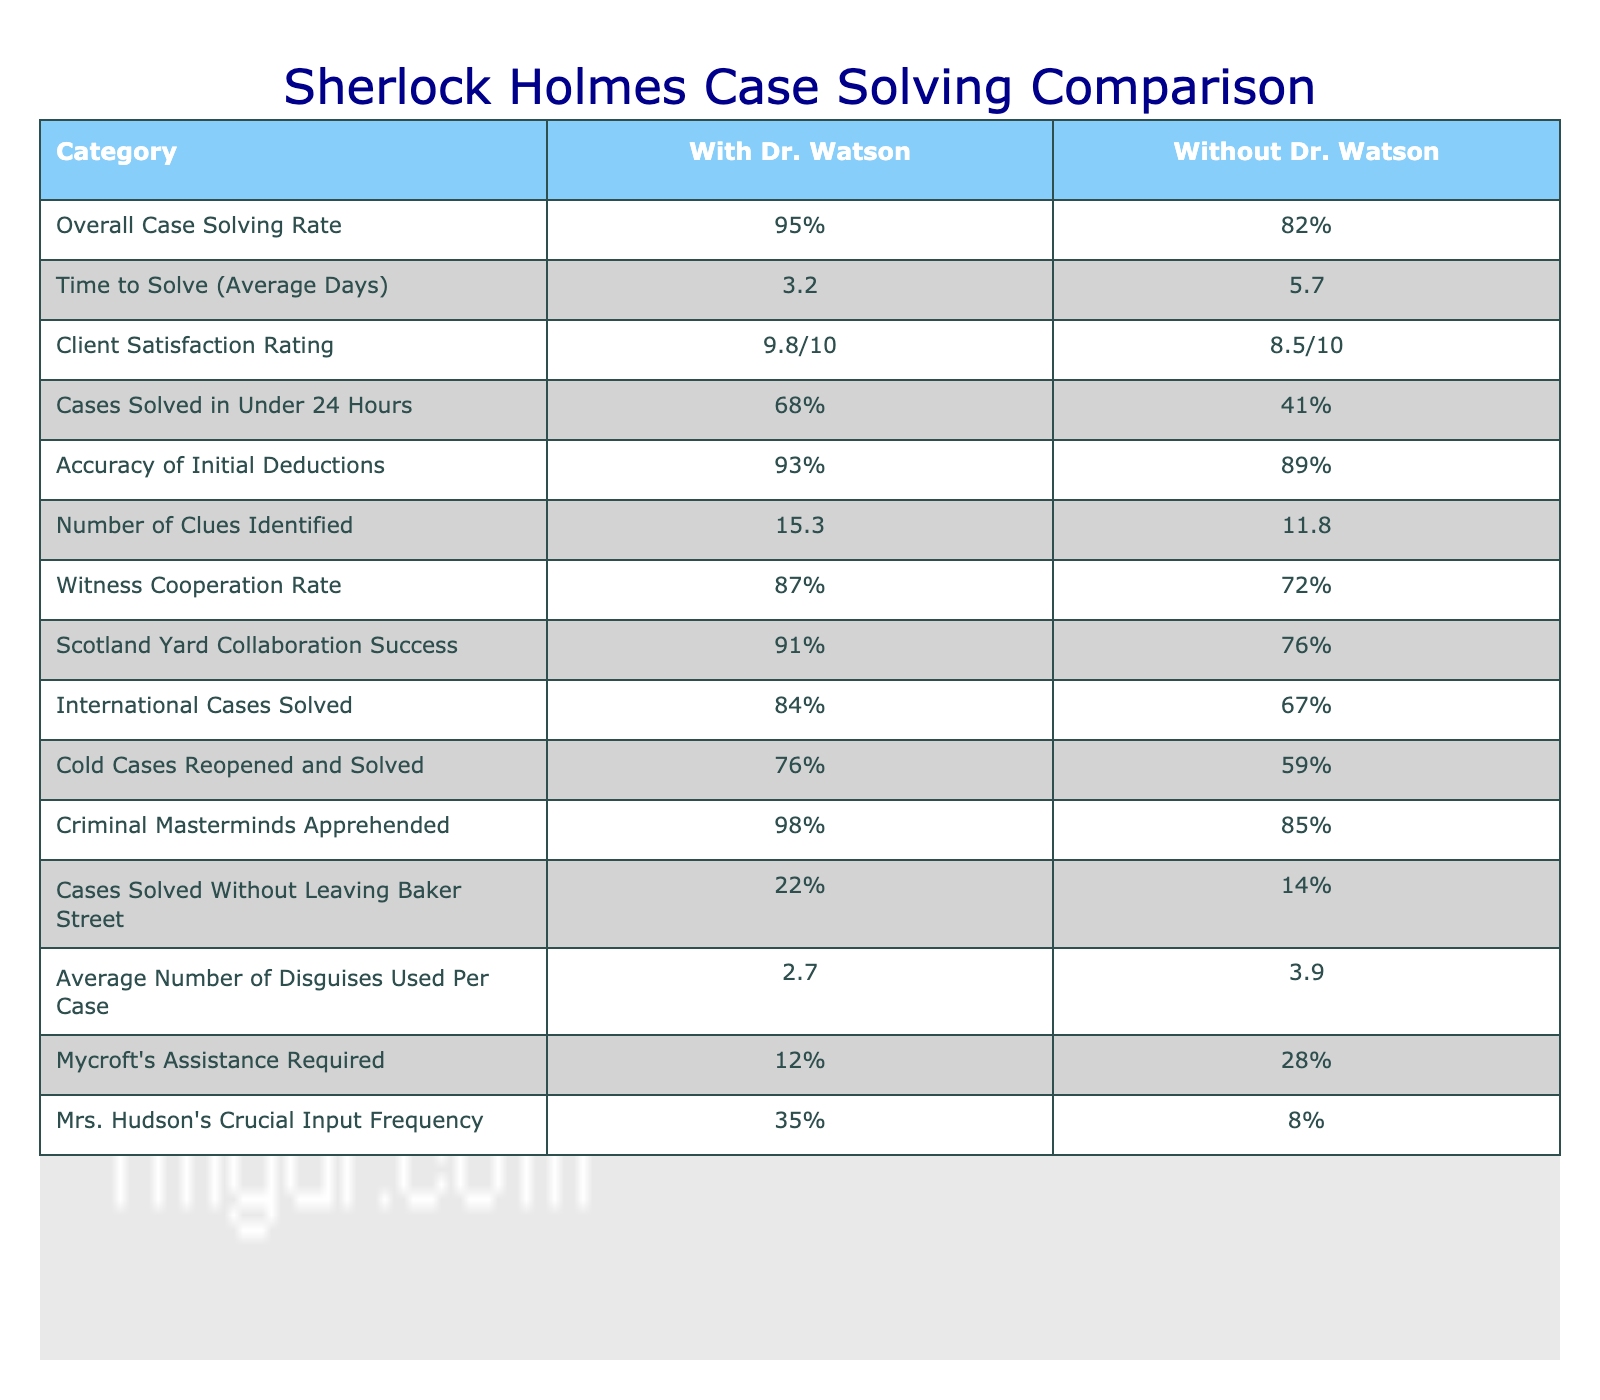What is the overall case solving rate with Dr. Watson's assistance? The table shows that the overall case solving rate with Dr. Watson is 95%.
Answer: 95% What is the average time to solve cases without Dr. Watson? The table indicates that the average time to solve cases without Dr. Watson is 5.7 days.
Answer: 5.7 How much higher is the client satisfaction rating with Dr. Watson compared to without? The client satisfaction rating with Dr. Watson is 9.8/10 and without is 8.5/10. The difference is 9.8 - 8.5 = 1.3.
Answer: 1.3 Did the rate of criminal masterminds apprehended improve with Dr. Watson's help? Yes, the rate increased from 85% without Dr. Watson to 98% with his assistance, indicating improvement.
Answer: Yes What is the percentage difference in the number of clues identified in cases with and without Dr. Watson? The number of clues identified with Dr. Watson is 15.3 and without is 11.8. The difference is 15.3 - 11.8 = 3.5. To find the percentage difference, we calculate (3.5 / 11.8) * 100, which is approximately 29.66%.
Answer: 29.66% What percentage of cases were solved without leaving Baker Street when Dr. Watson was present? According to the table, 22% of cases were solved without leaving Baker Street with Dr. Watson.
Answer: 22% How does the average number of disguises used per case change when Dr. Watson assists? The table shows that the average number of disguises used per case is 2.7 with Dr. Watson and 3.9 without, indicating a reduction of 1.2 disguises when Dr. Watson is present.
Answer: 1.2 Is the witness cooperation rate higher with or without Dr. Watson? The table indicates that the witness cooperation rate is 87% with Dr. Watson and 72% without. Therefore, it is higher with Dr. Watson.
Answer: Higher with Dr. Watson What is the average case solving rate for cold cases with Dr. Watson's assistance compared to without? The table data shows that cold cases reopened and solved is 76% with Dr. Watson and 59% without. Thus, cases solved with Dr. Watson is higher.
Answer: Higher with Dr. Watson By how much did the international cases solved increase due to Dr. Watson's assistance? The international cases solved with Dr. Watson is 84% and without him is 67%. The difference is 84 - 67 = 17%, showing an increase in solved international cases with Dr. Watson's help.
Answer: 17% 